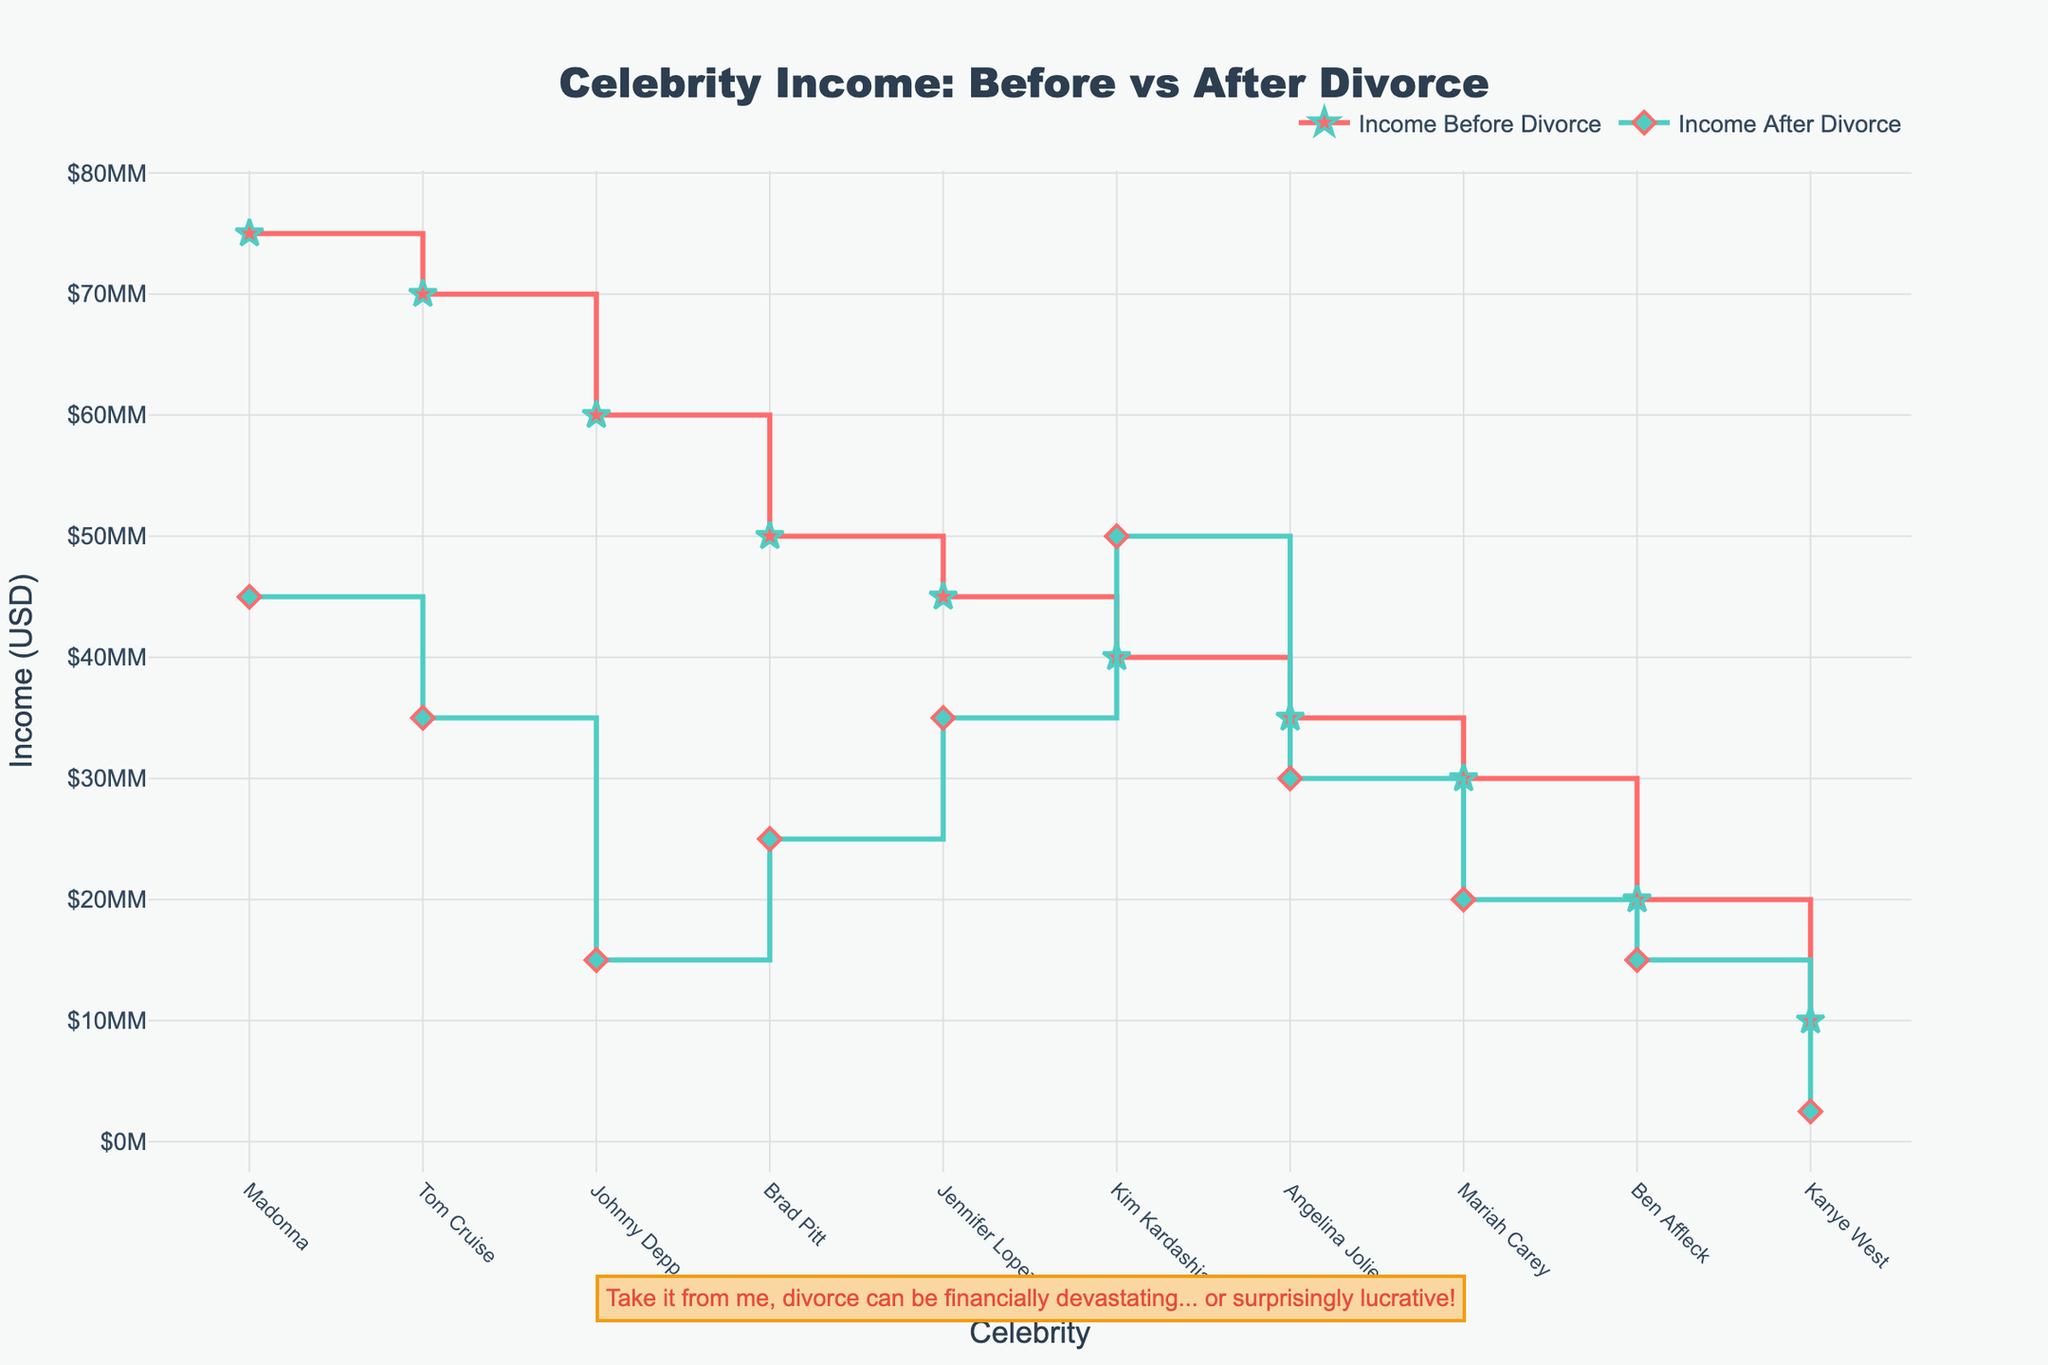Which celebrity had the highest income before divorce? By observing the highest point on the "Income Before Divorce" plot, we can identify that the highest income before divorce is represented by Madonna.
Answer: Madonna Which celebrity had an increase in income after divorce? Looking at the "Income Before Divorce" and "Income After Divorce" lines, we can see that Kim Kardashian's income marker moved upwards post-divorce, indicating an increase in her income.
Answer: Kim Kardashian What is the average income before and after divorce among the celebrities? To find the average, sum all the incomes before and after divorce respectively, then divide each sum by the number of celebrities (10). Sum: $60000000 + 35000000 + 50000000 + 75000000 + 30000000 + 70000000 + 40000000 + 10000000 + 20000000 + 45000000 = $435,000,000. The average income before divorce is $435,000,000 / 10 = $43,500,000. For after divorce: $15000000 + 30000000 + 25000000 + 45000000 + 20000000 + 35000000 + 50000000 + 2500000 + 15000000 + 35000000 = $272,500,000. The average income after divorce is $272,500,000 / 10 = $27,250,000.
Answer: Before: $43,500,000; After: $27,250,000 Which celebrity had the greatest reduction in income after divorce? By calculating the difference between "Income Before Divorce" and "Income After Divorce" for each celebrity, and comparing these differences, Madonna had the biggest drop: $75,000,000 - $45,000,000 = $30,000,000 loss.
Answer: Madonna Who had the smallest income change after divorce? Comparing the changes in income (absolute values), Angelina Jolie had the smallest change: $35,000,000 - $30,000,000 = $5,000,000.
Answer: Angelina Jolie How many celebrities had a reduction in their income after divorce? Observing the plot, count the number of celebrities whose "Income After Divorce" markers are lower than their "Income Before Divorce" markers. We see Johnny Depp, Brad Pitt, Madonna, Mariah Carey, Tom Cruise, Kanye West, Ben Affleck, and Jennifer Lopez which totals to 8.
Answer: 8 What's the total loss in income for all celebrities combined after divorce? First, calculate the total incomes before and after divorce, then find their difference. Total before: $435,000,000. Total after: $272,500,000. The combined loss: $435,000,000 - $272,500,000 = $162,500,000.
Answer: $162,500,000 Who has the highest income after divorce? Compare the final positions of the "Income After Divorce" markers and note that Kim Kardashian has the highest income after divorce of $50,000,000.
Answer: Kim Kardashian 